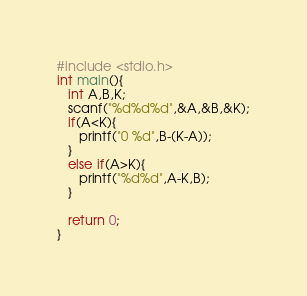<code> <loc_0><loc_0><loc_500><loc_500><_C_>#include <stdio.h>
int main(){
   int A,B,K;
   scanf("%d%d%d",&A,&B,&K);
   if(A<K){
      printf("0 %d",B-(K-A));
   }
   else if(A>K){
      printf("%d%d",A-K,B);
   }
   
   return 0;
}
</code> 